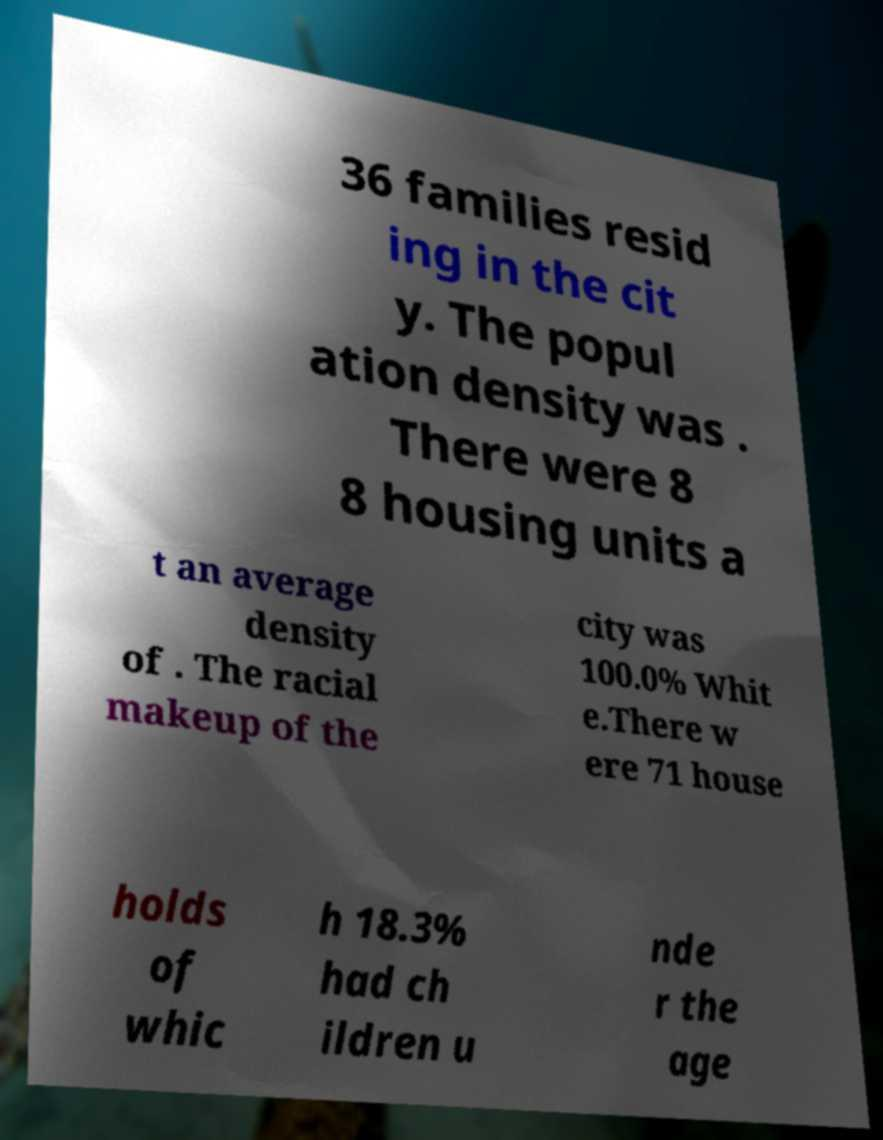What messages or text are displayed in this image? I need them in a readable, typed format. 36 families resid ing in the cit y. The popul ation density was . There were 8 8 housing units a t an average density of . The racial makeup of the city was 100.0% Whit e.There w ere 71 house holds of whic h 18.3% had ch ildren u nde r the age 